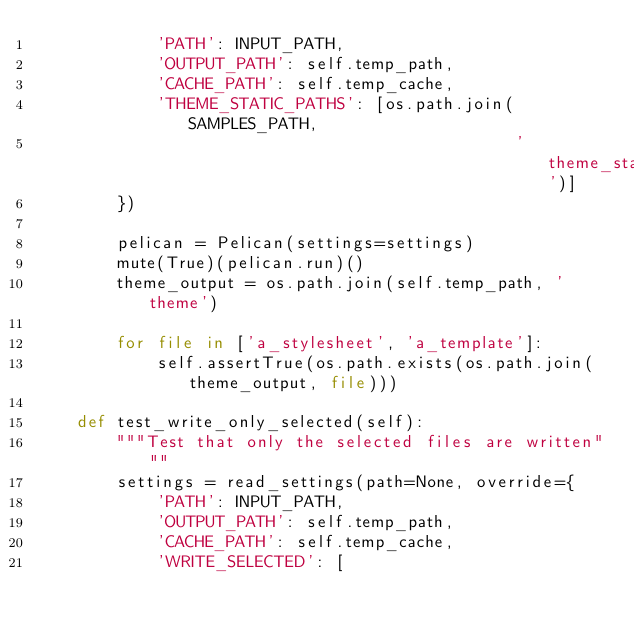<code> <loc_0><loc_0><loc_500><loc_500><_Python_>            'PATH': INPUT_PATH,
            'OUTPUT_PATH': self.temp_path,
            'CACHE_PATH': self.temp_cache,
            'THEME_STATIC_PATHS': [os.path.join(SAMPLES_PATH,
                                                'theme_standard')]
        })

        pelican = Pelican(settings=settings)
        mute(True)(pelican.run)()
        theme_output = os.path.join(self.temp_path, 'theme')

        for file in ['a_stylesheet', 'a_template']:
            self.assertTrue(os.path.exists(os.path.join(theme_output, file)))

    def test_write_only_selected(self):
        """Test that only the selected files are written"""
        settings = read_settings(path=None, override={
            'PATH': INPUT_PATH,
            'OUTPUT_PATH': self.temp_path,
            'CACHE_PATH': self.temp_cache,
            'WRITE_SELECTED': [</code> 